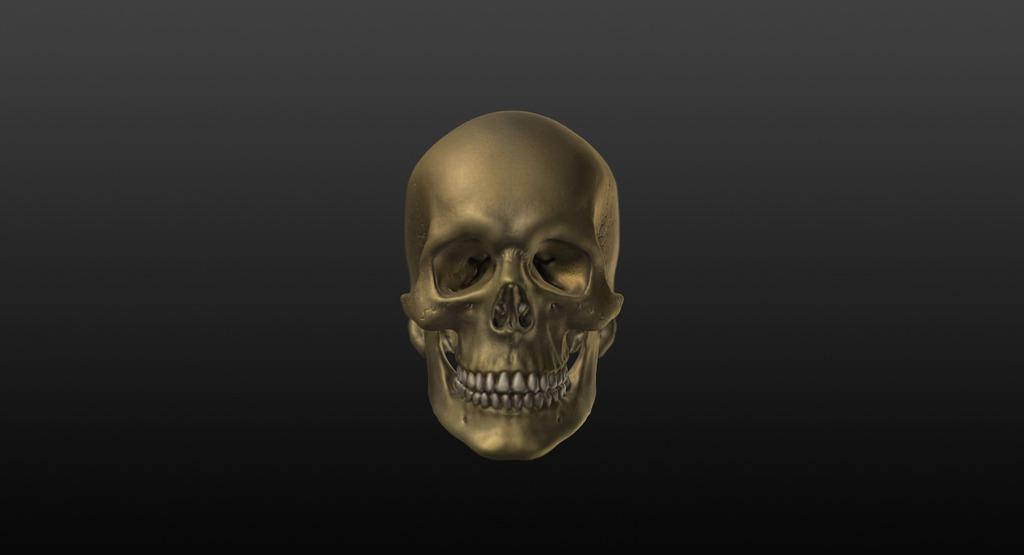What type of image is being described? The image is animated. What is the main subject of the animated image? The image depicts a human skull. What design is featured on the dime in the image? There is no dime present in the image; it only depicts a human skull. How many hands are visible in the image? There are no hands visible in the image; it only depicts a human skull. 